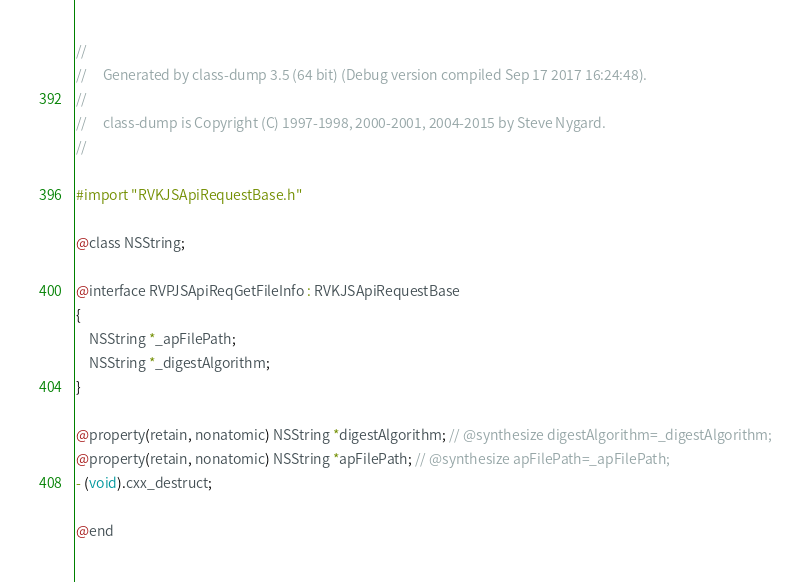Convert code to text. <code><loc_0><loc_0><loc_500><loc_500><_C_>//
//     Generated by class-dump 3.5 (64 bit) (Debug version compiled Sep 17 2017 16:24:48).
//
//     class-dump is Copyright (C) 1997-1998, 2000-2001, 2004-2015 by Steve Nygard.
//

#import "RVKJSApiRequestBase.h"

@class NSString;

@interface RVPJSApiReqGetFileInfo : RVKJSApiRequestBase
{
    NSString *_apFilePath;
    NSString *_digestAlgorithm;
}

@property(retain, nonatomic) NSString *digestAlgorithm; // @synthesize digestAlgorithm=_digestAlgorithm;
@property(retain, nonatomic) NSString *apFilePath; // @synthesize apFilePath=_apFilePath;
- (void).cxx_destruct;

@end

</code> 